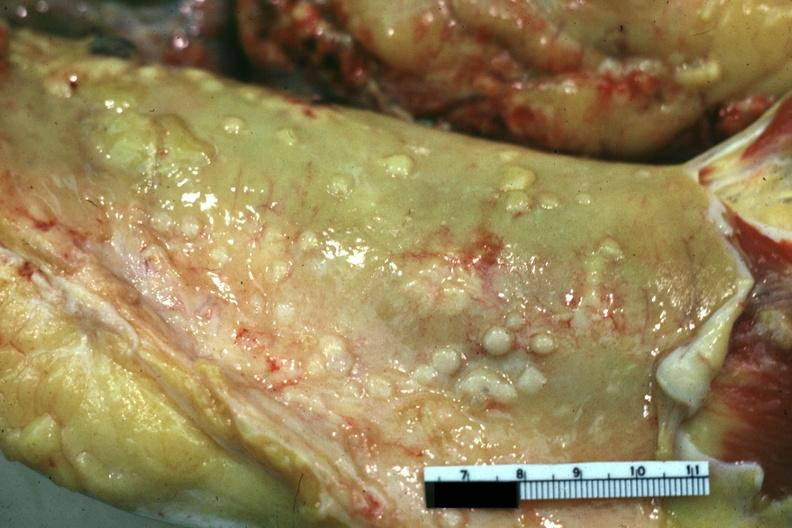what is present?
Answer the question using a single word or phrase. Peritoneum 